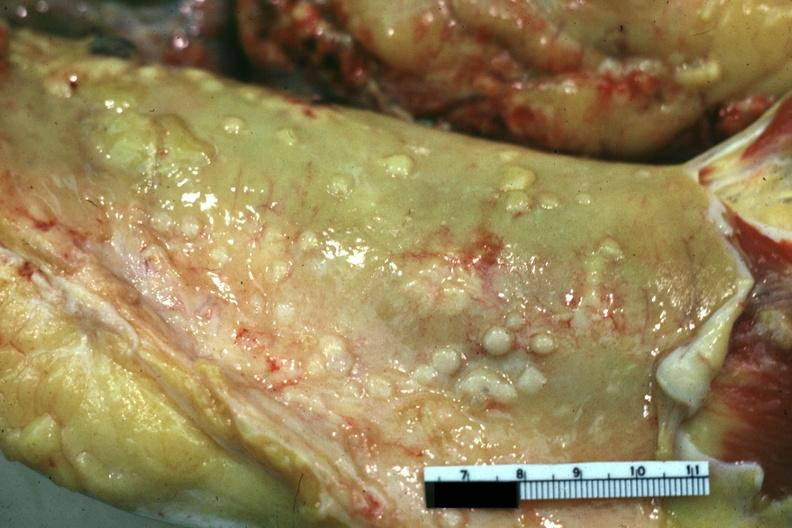what is present?
Answer the question using a single word or phrase. Peritoneum 